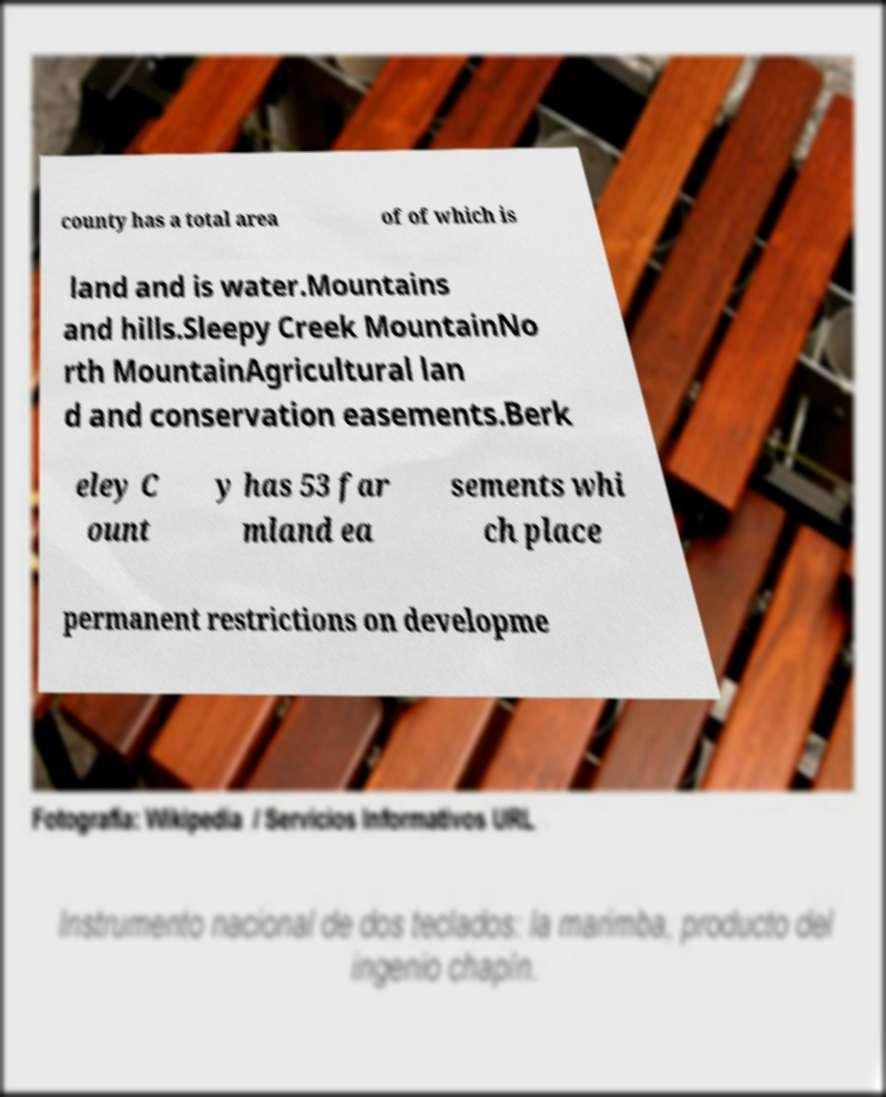I need the written content from this picture converted into text. Can you do that? county has a total area of of which is land and is water.Mountains and hills.Sleepy Creek MountainNo rth MountainAgricultural lan d and conservation easements.Berk eley C ount y has 53 far mland ea sements whi ch place permanent restrictions on developme 